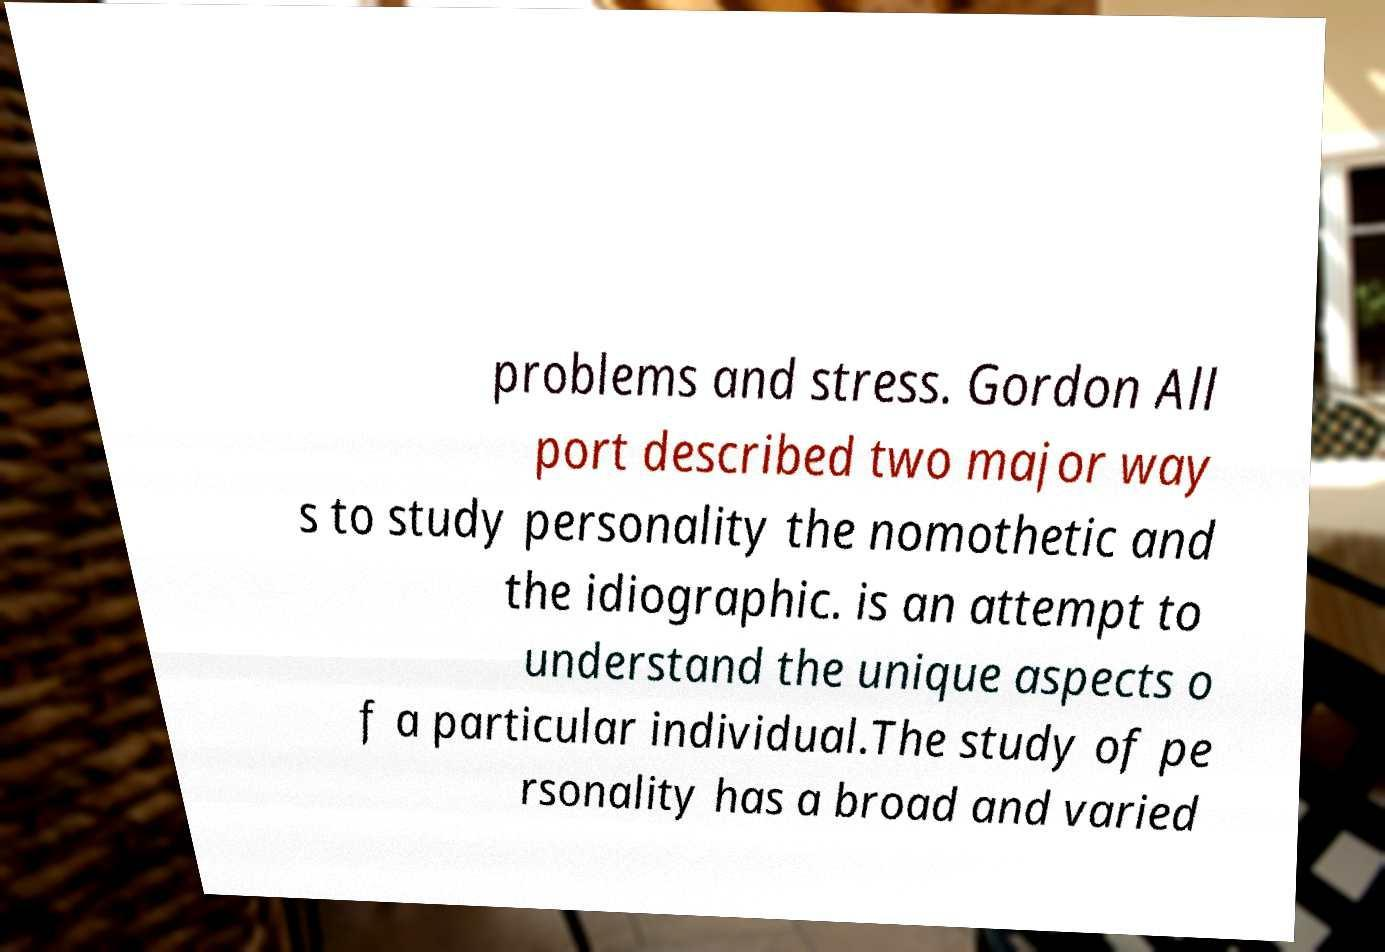Please identify and transcribe the text found in this image. problems and stress. Gordon All port described two major way s to study personality the nomothetic and the idiographic. is an attempt to understand the unique aspects o f a particular individual.The study of pe rsonality has a broad and varied 